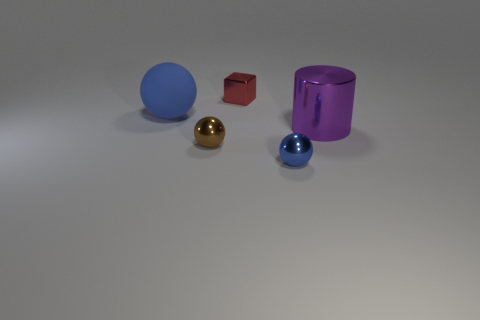Add 4 tiny red rubber cylinders. How many objects exist? 9 Subtract all cylinders. How many objects are left? 4 Add 2 big yellow shiny cubes. How many big yellow shiny cubes exist? 2 Subtract 1 purple cylinders. How many objects are left? 4 Subtract all tiny red cubes. Subtract all blue balls. How many objects are left? 2 Add 1 big things. How many big things are left? 3 